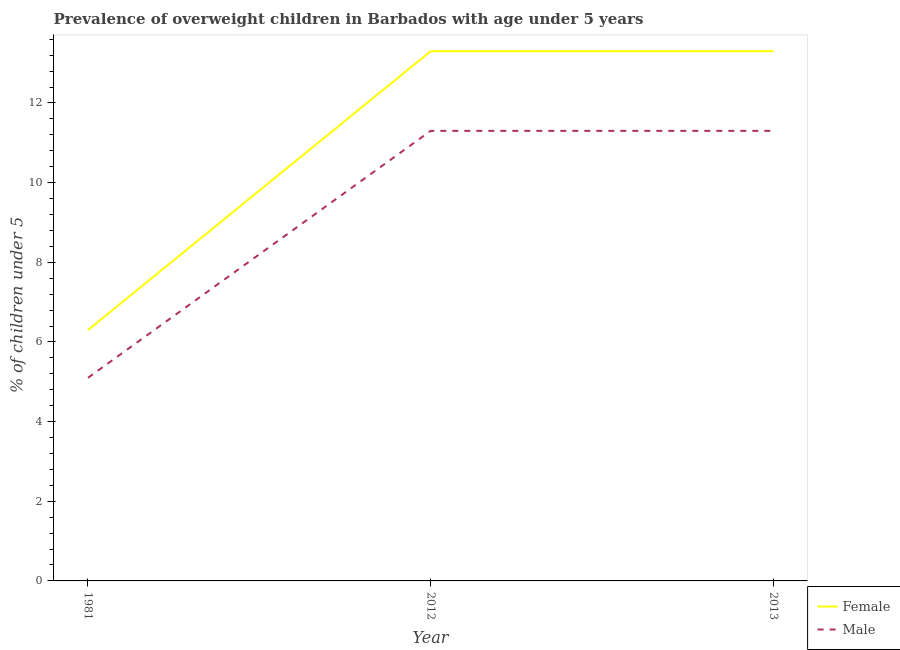Does the line corresponding to percentage of obese female children intersect with the line corresponding to percentage of obese male children?
Your response must be concise. No. Is the number of lines equal to the number of legend labels?
Provide a short and direct response. Yes. What is the percentage of obese female children in 2012?
Your answer should be very brief. 13.3. Across all years, what is the maximum percentage of obese female children?
Your answer should be compact. 13.3. Across all years, what is the minimum percentage of obese male children?
Give a very brief answer. 5.1. In which year was the percentage of obese male children maximum?
Your response must be concise. 2012. What is the total percentage of obese male children in the graph?
Provide a short and direct response. 27.7. What is the difference between the percentage of obese female children in 1981 and that in 2012?
Your response must be concise. -7. What is the difference between the percentage of obese female children in 2012 and the percentage of obese male children in 2013?
Ensure brevity in your answer.  2. What is the average percentage of obese female children per year?
Offer a terse response. 10.97. In the year 1981, what is the difference between the percentage of obese female children and percentage of obese male children?
Offer a very short reply. 1.2. What is the ratio of the percentage of obese female children in 1981 to that in 2012?
Provide a short and direct response. 0.47. Is the difference between the percentage of obese female children in 1981 and 2013 greater than the difference between the percentage of obese male children in 1981 and 2013?
Provide a short and direct response. No. What is the difference between the highest and the second highest percentage of obese male children?
Your answer should be very brief. 1.907348998742009e-7. What is the difference between the highest and the lowest percentage of obese male children?
Provide a short and direct response. 6.2. Is the sum of the percentage of obese male children in 2012 and 2013 greater than the maximum percentage of obese female children across all years?
Give a very brief answer. Yes. How many lines are there?
Provide a short and direct response. 2. How many years are there in the graph?
Give a very brief answer. 3. Are the values on the major ticks of Y-axis written in scientific E-notation?
Give a very brief answer. No. Does the graph contain grids?
Your answer should be very brief. No. How many legend labels are there?
Provide a succinct answer. 2. How are the legend labels stacked?
Provide a short and direct response. Vertical. What is the title of the graph?
Your answer should be compact. Prevalence of overweight children in Barbados with age under 5 years. What is the label or title of the Y-axis?
Keep it short and to the point.  % of children under 5. What is the  % of children under 5 of Female in 1981?
Ensure brevity in your answer.  6.3. What is the  % of children under 5 in Male in 1981?
Your response must be concise. 5.1. What is the  % of children under 5 in Female in 2012?
Your response must be concise. 13.3. What is the  % of children under 5 in Male in 2012?
Your answer should be very brief. 11.3. What is the  % of children under 5 in Female in 2013?
Offer a terse response. 13.3. Across all years, what is the maximum  % of children under 5 of Female?
Keep it short and to the point. 13.3. Across all years, what is the maximum  % of children under 5 in Male?
Keep it short and to the point. 11.3. Across all years, what is the minimum  % of children under 5 of Female?
Provide a succinct answer. 6.3. Across all years, what is the minimum  % of children under 5 in Male?
Your answer should be compact. 5.1. What is the total  % of children under 5 in Female in the graph?
Offer a very short reply. 32.9. What is the total  % of children under 5 of Male in the graph?
Your answer should be compact. 27.7. What is the difference between the  % of children under 5 in Female in 1981 and that in 2012?
Your answer should be compact. -7. What is the difference between the  % of children under 5 in Male in 1981 and that in 2012?
Ensure brevity in your answer.  -6.2. What is the difference between the  % of children under 5 in Female in 1981 and that in 2013?
Offer a very short reply. -7. What is the difference between the  % of children under 5 in Male in 2012 and that in 2013?
Keep it short and to the point. 0. What is the average  % of children under 5 in Female per year?
Your response must be concise. 10.97. What is the average  % of children under 5 of Male per year?
Make the answer very short. 9.23. In the year 2012, what is the difference between the  % of children under 5 of Female and  % of children under 5 of Male?
Your response must be concise. 2. What is the ratio of the  % of children under 5 in Female in 1981 to that in 2012?
Provide a short and direct response. 0.47. What is the ratio of the  % of children under 5 of Male in 1981 to that in 2012?
Your answer should be compact. 0.45. What is the ratio of the  % of children under 5 of Female in 1981 to that in 2013?
Your response must be concise. 0.47. What is the ratio of the  % of children under 5 of Male in 1981 to that in 2013?
Keep it short and to the point. 0.45. What is the difference between the highest and the second highest  % of children under 5 of Male?
Ensure brevity in your answer.  0. What is the difference between the highest and the lowest  % of children under 5 in Female?
Offer a very short reply. 7. What is the difference between the highest and the lowest  % of children under 5 of Male?
Provide a short and direct response. 6.2. 